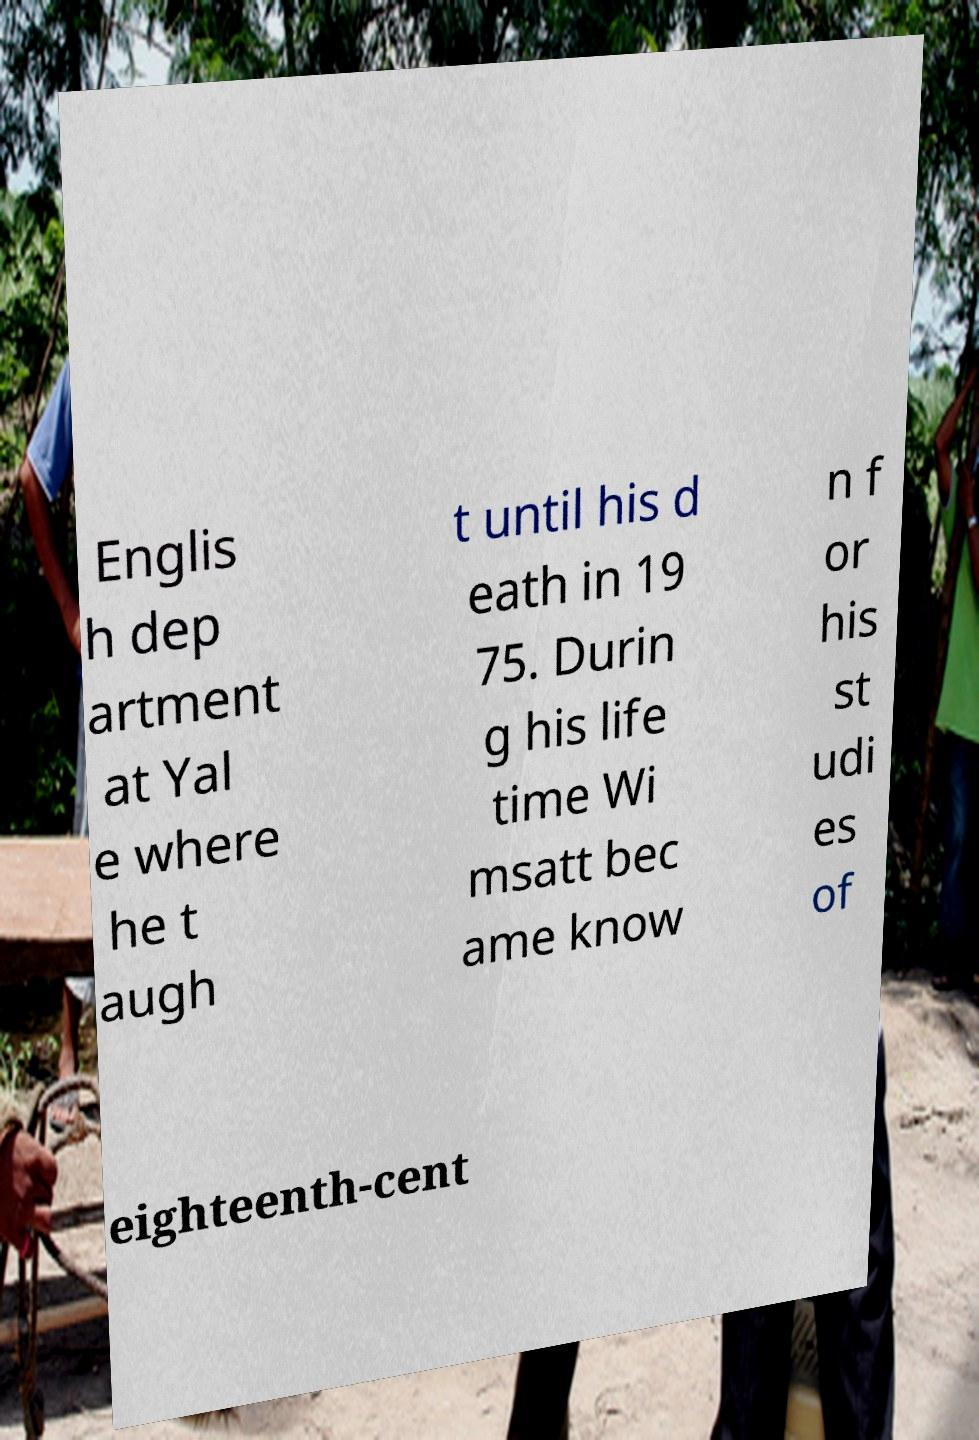For documentation purposes, I need the text within this image transcribed. Could you provide that? Englis h dep artment at Yal e where he t augh t until his d eath in 19 75. Durin g his life time Wi msatt bec ame know n f or his st udi es of eighteenth-cent 